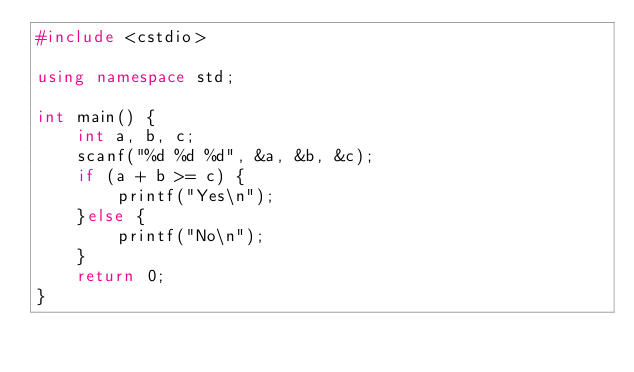<code> <loc_0><loc_0><loc_500><loc_500><_C++_>#include <cstdio>

using namespace std;

int main() {
    int a, b, c;
    scanf("%d %d %d", &a, &b, &c);
    if (a + b >= c) {
        printf("Yes\n");
    }else {
        printf("No\n");
    }
    return 0;
}
</code> 